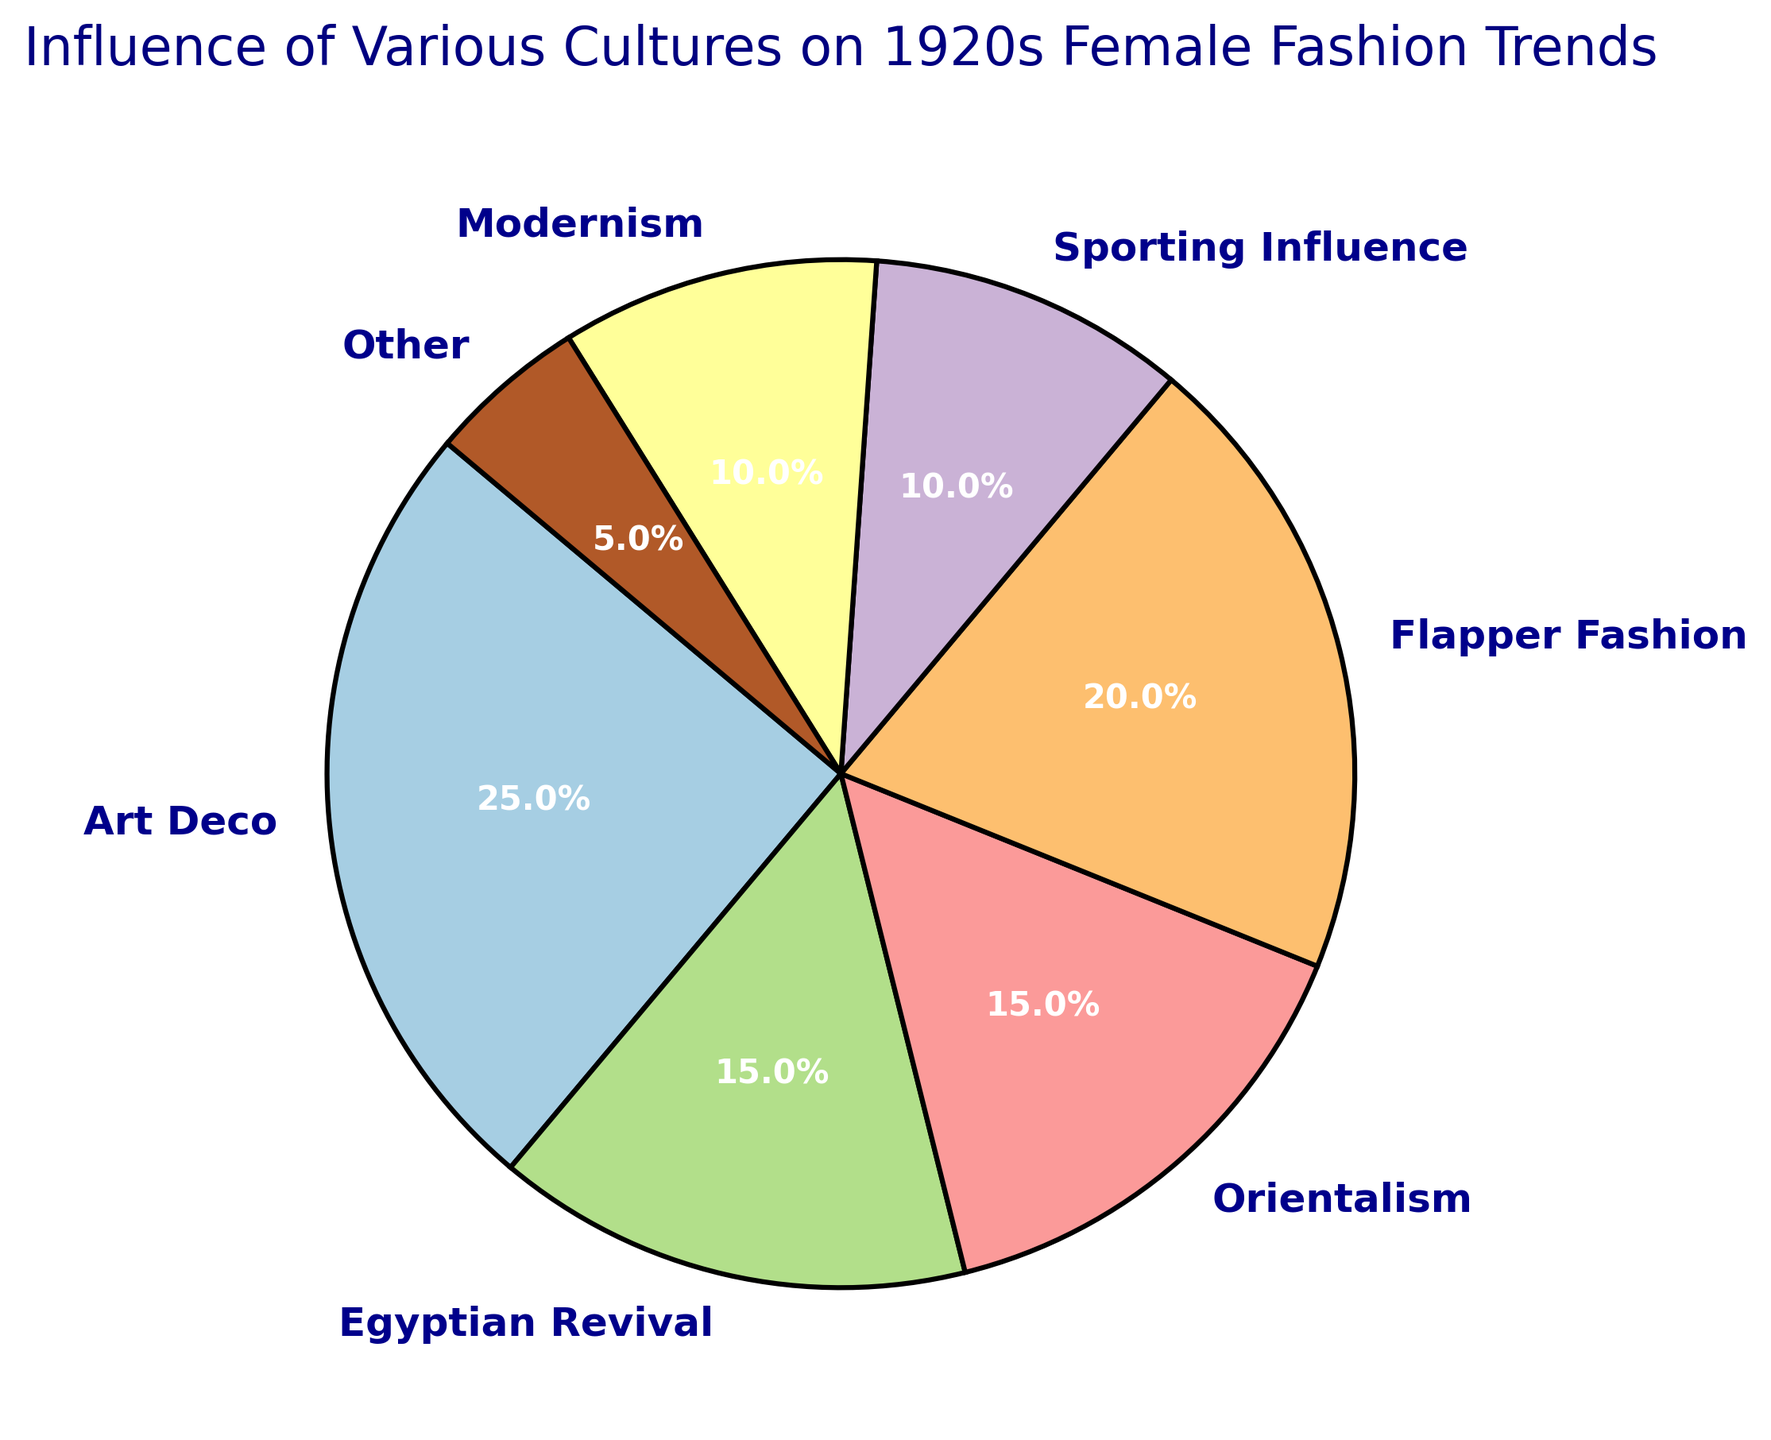What's the culture with the highest influence on 1920s female fashion trends depicted in the pie chart? The slice with the highest percentage in the pie chart represents the culture with the highest influence. According to the chart, "Art Deco" occupies 25%, the largest segment.
Answer: Art Deco Which cultures each have 15% influence on the 1920s female fashion trends? By observing the pie chart, we see the segments labeled with 15%. These segments are "Egyptian Revival" and "Orientalism."
Answer: Egyptian Revival and Orientalism What's the combined percentage influence of Flapper Fashion and Modernism? Sum the percentages of both Flapper Fashion (20%) and Modernism (10%). 20% + 10% = 30%
Answer: 30% Compare the influence of Sporting Influence and Other cultures. Which is higher? The pie chart shows the percentages for Sporting Influence and Other cultures. Sporting Influence has 10%, and Other has 5%. Sporting Influence is higher.
Answer: Sporting Influence How much more influence does Art Deco have compared to Modernism? Subtract the percentage of Modernism from that of Art Deco: 25% - 10% = 15%
Answer: 15% What is the visual difference in color between the segment representing Flapper Fashion and that representing Egyptian Revival? By observing the pie chart's color coding, we can describe the visual distinction. Noting the specific colors used: Flapper Fashion is distinct from Egyptian Revival color.
Answer: Flapper Fashion and Egyptian Revival have different colors Calculate the average influence of Egyptian Revival, Orientalism, and Modernism combined. First, find the sum of their percentages (Egyptian Revival 15% + Orientalism 15% + Modernism 10%). Then divide by the number of cultures: (15% + 15% + 10%) / 3 = 40% / 3 ≈ 13.33%
Answer: 13.33% Which culture has the least influence, and what is its percentage? The smallest slice in the pie chart represents the culture with the least influence. "Other" is the smallest segment with a 5% influence.
Answer: Other, 5% Describe the position of the Flapper Fashion segment within the pie chart. The pie chart's segments are organized in a circular pattern. The Flapper Fashion segment is positioned in the middle portion.
Answer: Middle portion 